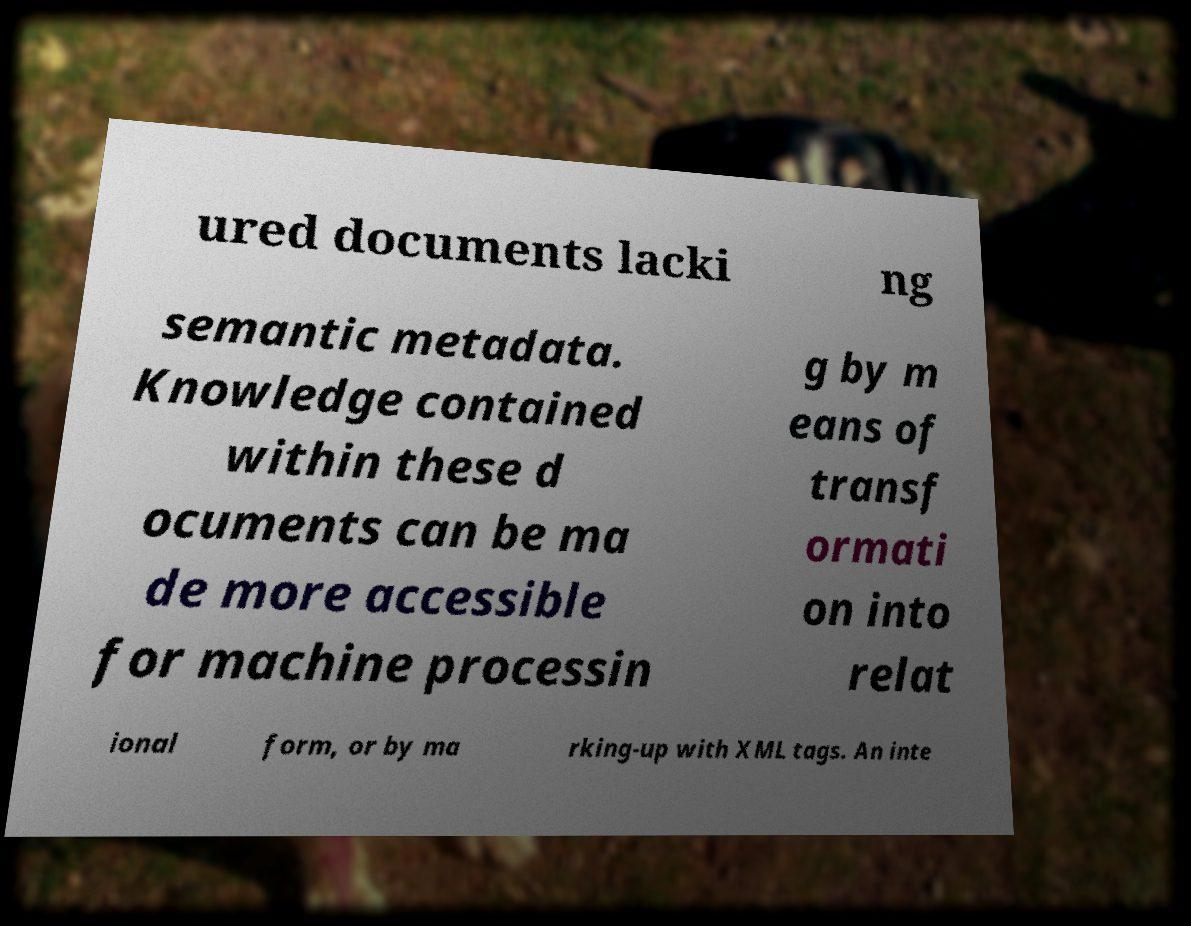Can you accurately transcribe the text from the provided image for me? ured documents lacki ng semantic metadata. Knowledge contained within these d ocuments can be ma de more accessible for machine processin g by m eans of transf ormati on into relat ional form, or by ma rking-up with XML tags. An inte 